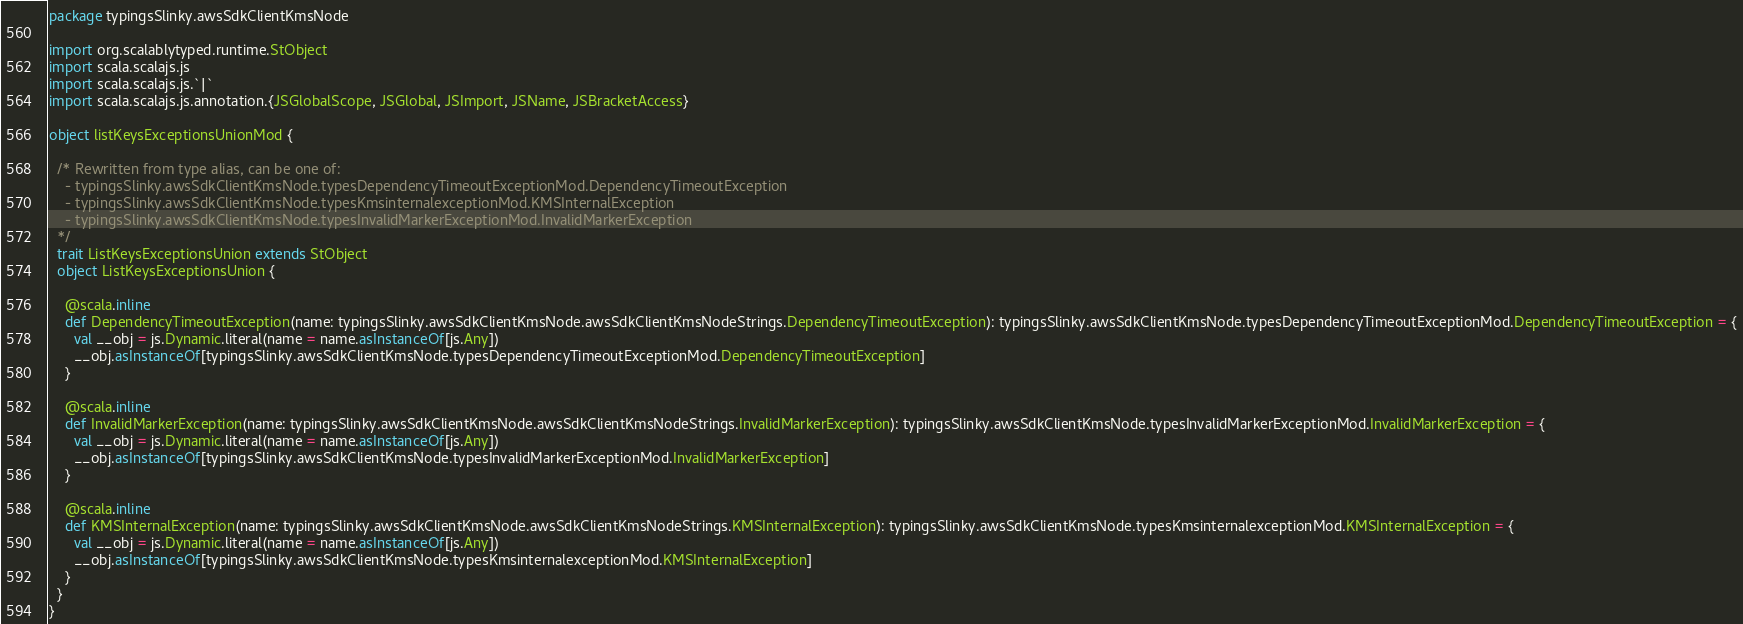<code> <loc_0><loc_0><loc_500><loc_500><_Scala_>package typingsSlinky.awsSdkClientKmsNode

import org.scalablytyped.runtime.StObject
import scala.scalajs.js
import scala.scalajs.js.`|`
import scala.scalajs.js.annotation.{JSGlobalScope, JSGlobal, JSImport, JSName, JSBracketAccess}

object listKeysExceptionsUnionMod {
  
  /* Rewritten from type alias, can be one of: 
    - typingsSlinky.awsSdkClientKmsNode.typesDependencyTimeoutExceptionMod.DependencyTimeoutException
    - typingsSlinky.awsSdkClientKmsNode.typesKmsinternalexceptionMod.KMSInternalException
    - typingsSlinky.awsSdkClientKmsNode.typesInvalidMarkerExceptionMod.InvalidMarkerException
  */
  trait ListKeysExceptionsUnion extends StObject
  object ListKeysExceptionsUnion {
    
    @scala.inline
    def DependencyTimeoutException(name: typingsSlinky.awsSdkClientKmsNode.awsSdkClientKmsNodeStrings.DependencyTimeoutException): typingsSlinky.awsSdkClientKmsNode.typesDependencyTimeoutExceptionMod.DependencyTimeoutException = {
      val __obj = js.Dynamic.literal(name = name.asInstanceOf[js.Any])
      __obj.asInstanceOf[typingsSlinky.awsSdkClientKmsNode.typesDependencyTimeoutExceptionMod.DependencyTimeoutException]
    }
    
    @scala.inline
    def InvalidMarkerException(name: typingsSlinky.awsSdkClientKmsNode.awsSdkClientKmsNodeStrings.InvalidMarkerException): typingsSlinky.awsSdkClientKmsNode.typesInvalidMarkerExceptionMod.InvalidMarkerException = {
      val __obj = js.Dynamic.literal(name = name.asInstanceOf[js.Any])
      __obj.asInstanceOf[typingsSlinky.awsSdkClientKmsNode.typesInvalidMarkerExceptionMod.InvalidMarkerException]
    }
    
    @scala.inline
    def KMSInternalException(name: typingsSlinky.awsSdkClientKmsNode.awsSdkClientKmsNodeStrings.KMSInternalException): typingsSlinky.awsSdkClientKmsNode.typesKmsinternalexceptionMod.KMSInternalException = {
      val __obj = js.Dynamic.literal(name = name.asInstanceOf[js.Any])
      __obj.asInstanceOf[typingsSlinky.awsSdkClientKmsNode.typesKmsinternalexceptionMod.KMSInternalException]
    }
  }
}
</code> 